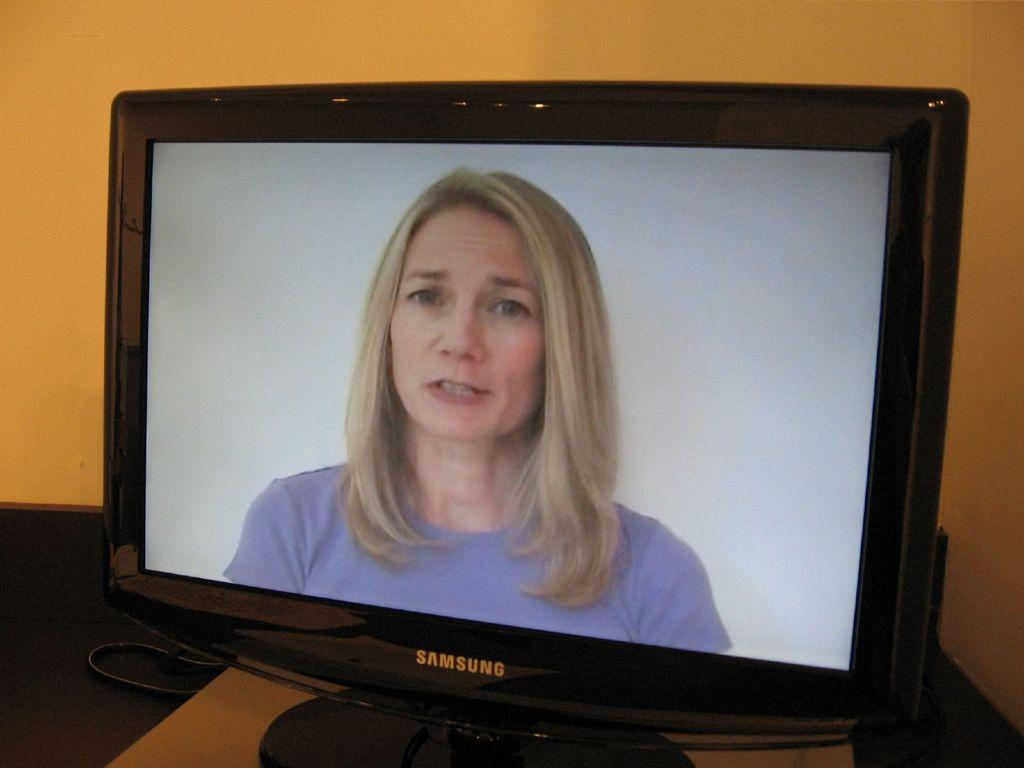<image>
Describe the image concisely. A samsung monitor shows a woman in a blue shirt. 